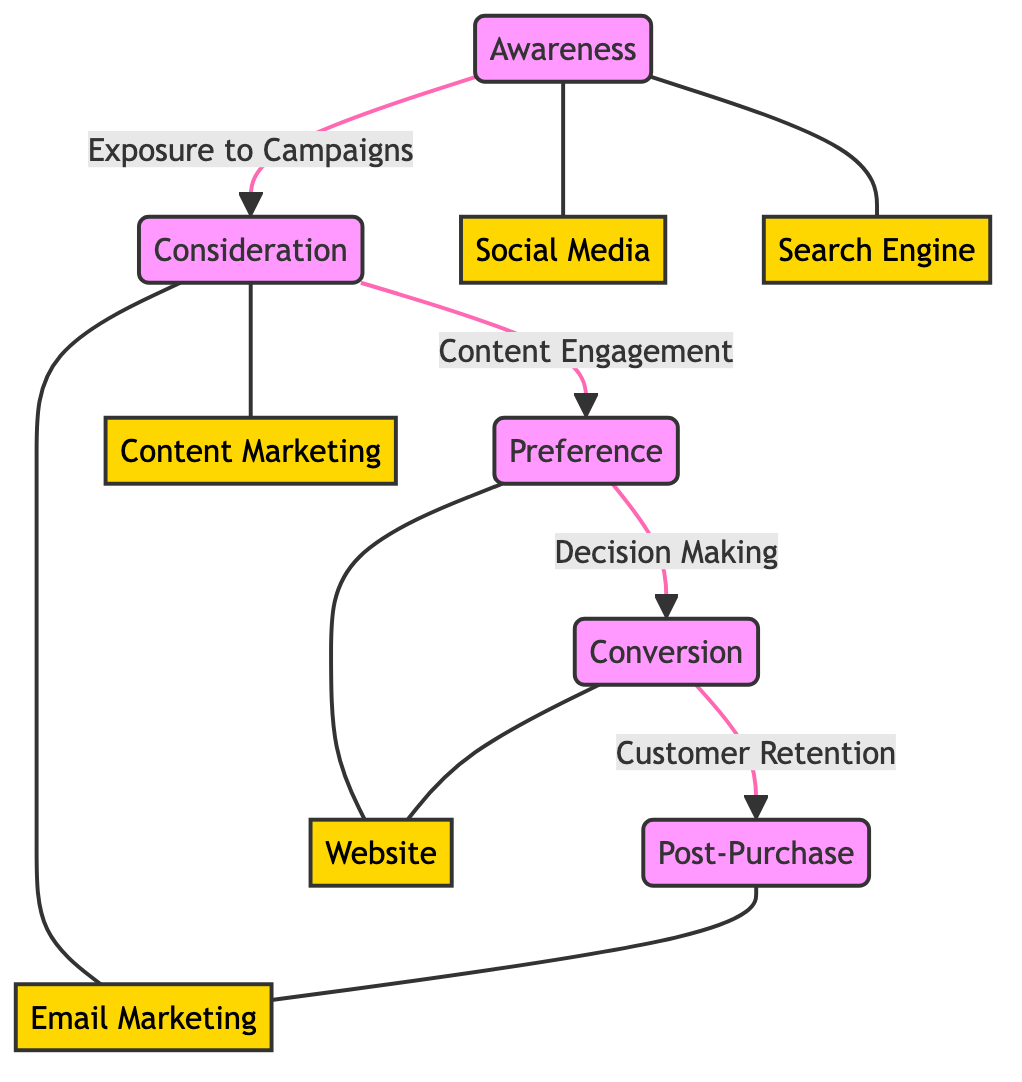What are the four main stages of the consumer journey? The diagram identifies four main stages: Awareness, Consideration, Preference, and Conversion. These are clearly labeled as nodes within the diagram.
Answer: Awareness, Consideration, Preference, Conversion How many touchpoints are associated with the Awareness stage? By examining the edges connected to the Awareness node, we see it links to two touchpoints: Social Media and Search Engine. Thus, there are two associated touchpoints.
Answer: 2 What type of engagement happens at the Consideration stage? The edge connecting the Awareness and Consideration nodes is labeled as "Exposure to Campaigns," while the edge between Consideration and Preference is labeled "Content Engagement," indicating the specific type of engagement at the Consideration stage.
Answer: Content Engagement Which touchpoint leads to the Preference stage? The touchpoint that leads to the Preference stage is identified in the diagram as Content Marketing, which is connected to the Consideration node.
Answer: Content Marketing What is the primary action leading to Conversion? The diagram indicates that the action leading to Conversion is "Decision Making," which connects the Preference stage to the Conversion node.
Answer: Decision Making How does a consumer transition from Conversion to Post-Purchase? The diagram clearly states that the transition from Conversion to Post-Purchase occurs through "Customer Retention," connecting these two stages directly.
Answer: Customer Retention Which touchpoint is associated with Post-Purchase? The diagram indicates that the touchpoint associated with Post-Purchase is Email Marketing, which is explicitly connected to the Post-Purchase node.
Answer: Email Marketing What type of diagram is this? This representation is a flowchart, specifically a Textbook Diagram, as denoted by the use of nodes to describe processes and the labeled edges connecting these nodes.
Answer: Flowchart 